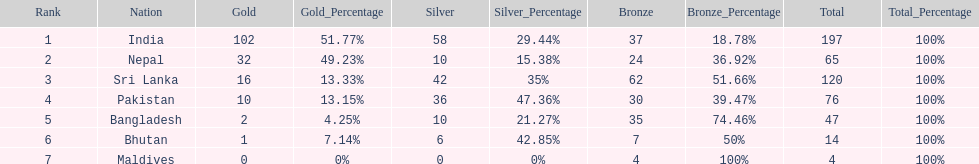What is the difference in total number of medals between india and nepal? 132. 